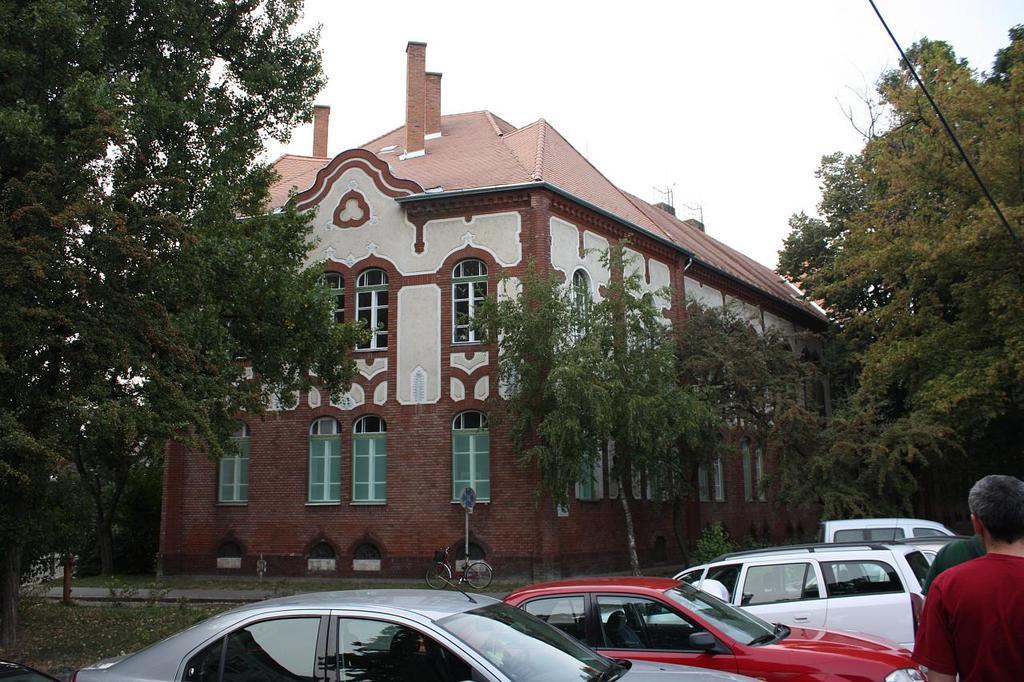How would you summarize this image in a sentence or two? In this image I can see the vehicles. To the right I can see few people. In the background I can see the trees, building with windows and the sky. 